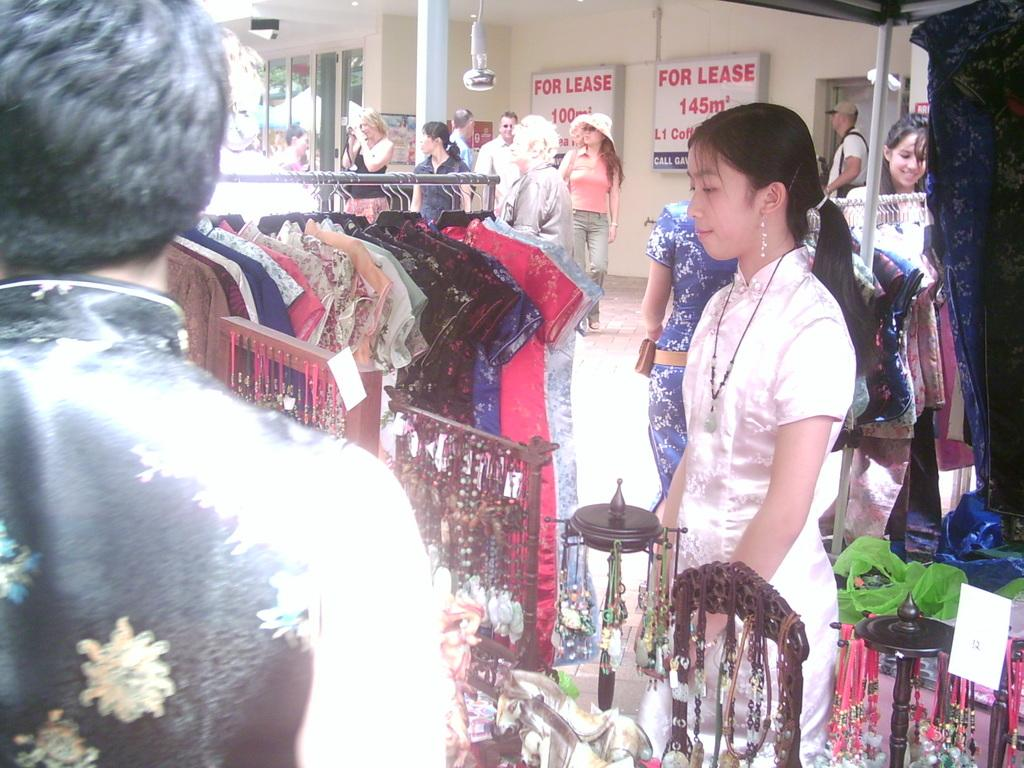What is present on the rod in the image? Clothes are hanging on a rod in the image. Who is in the image? There are people in the image. What is on the wall in the image? There are boards on a wall in the image, and something is written on them. What other structures can be seen in the image? There is a wall, a pillar, and a pole in the image. What else is present in the image besides the people and structures? Objects are present in the image. What type of nose is visible on the selection of clothes in the image? There is no nose present in the image; it features clothes hanging on a rod. What wish can be granted by the people in the image? There is no mention of wishes or granting them in the image. 